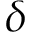Convert formula to latex. <formula><loc_0><loc_0><loc_500><loc_500>\delta</formula> 